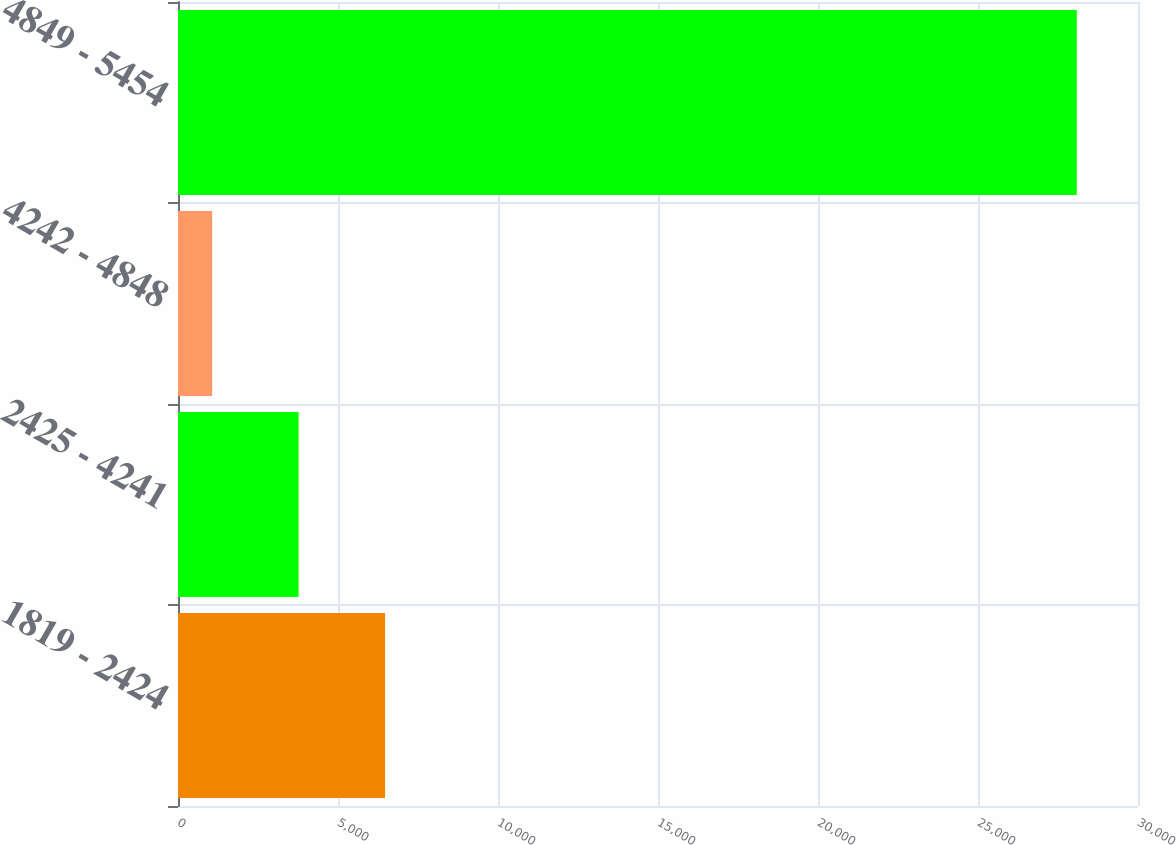Convert chart. <chart><loc_0><loc_0><loc_500><loc_500><bar_chart><fcel>1819 - 2424<fcel>2425 - 4241<fcel>4242 - 4848<fcel>4849 - 5454<nl><fcel>6471<fcel>3769<fcel>1067<fcel>28087<nl></chart> 